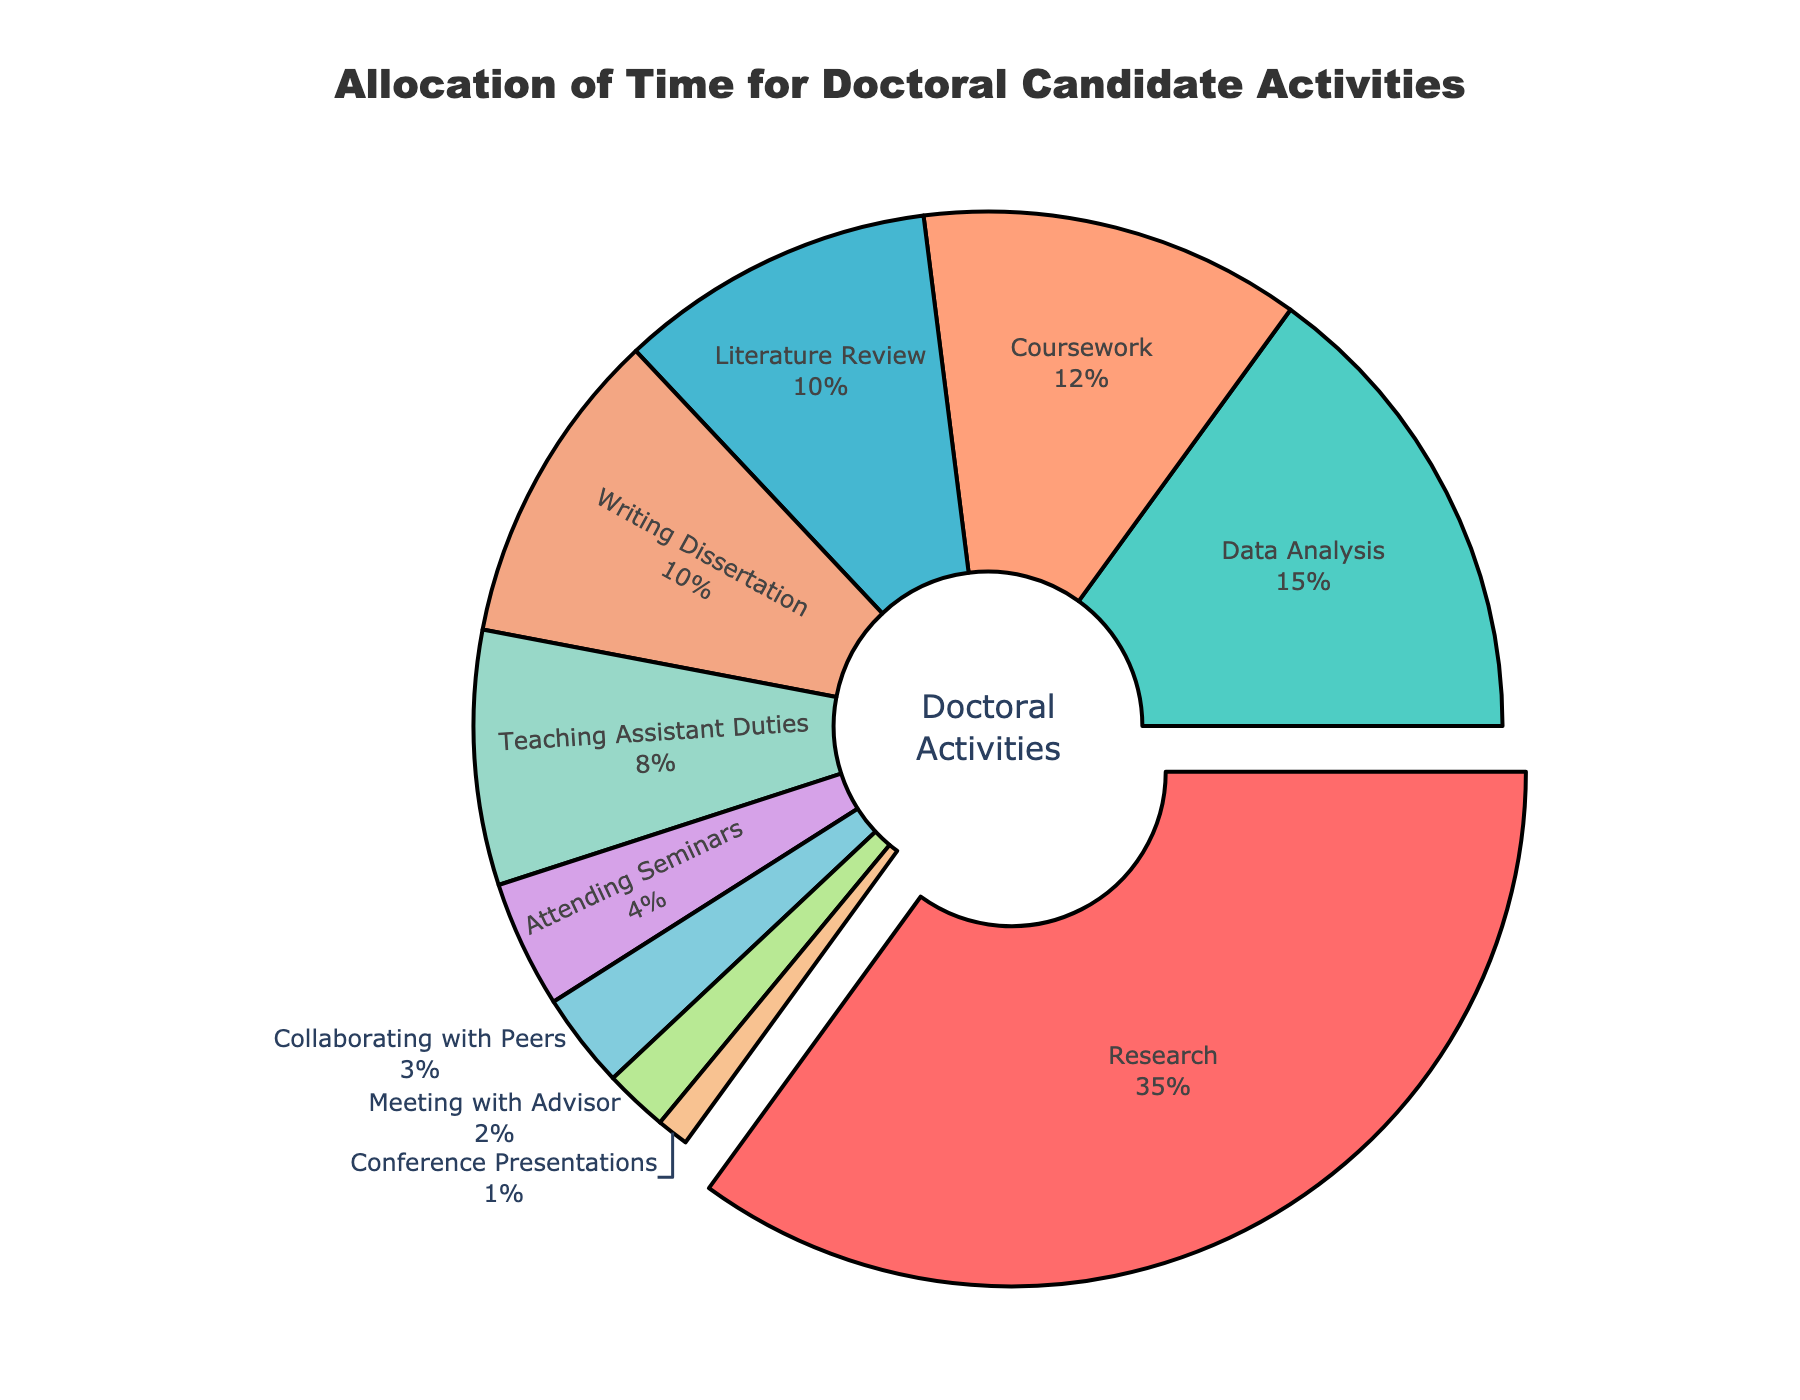What's the largest activity category shown in the pie chart? The largest category is pulled slightly away from the center of the pie chart for emphasis. This can be visually identified without referring to the percentages.
Answer: Research How much more time is spent on Research compared to Teaching Assistant Duties? First, identify the percentages for Research (35%) and Teaching Assistant Duties (8%) from the pie chart. Subtract the two to find the difference: 35% - 8% = 27%
Answer: 27% What is the total percentage of time spent on Writing Dissertation and Literature Review combined? Locate the percentages for Writing Dissertation (10%) and Literature Review (10%). Add these values together: 10% + 10% = 20%
Answer: 20% Which activity is represented by the green color in the pie chart? Identify the green-colored segment in the pie chart and refer to its label. The green color corresponds to Coursework with 12% of time allocation.
Answer: Coursework What percentage of time is spent on activities other than Research and Coursework? Find the percentages for Research (35%) and Coursework (12%). Subtract their sum from 100% to find the percentage spent on activities other than these two: 100% - (35% + 12%) = 100% - 47% = 53%
Answer: 53% How many activities individually account for 10% or more of the total time? Identify the activities with percentages 10% or higher: Research (35%), Writing Dissertation (10%), Coursework (12%), and Data Analysis (15%). There are 4 such activities.
Answer: 4 Which two activities combined have a similar percentage to Data Analysis? Identify the percentage for Data Analysis (15%). Next, look for two activities whose combined percentage approximates 15%. Literature Review (10%) and Attending Seminars (4%) together total 14%, which is closest.
Answer: Literature Review and Attending Seminars What is the median percentage value for all activities? Sort the activities based on their percentages: 1%, 2%, 3%, 4%, 8%, 10%, 10%, 12%, 15%, 35%. The median (middle) value, based on the sorted list, is the average of the 5th and 6th values: (8% + 10%) / 2 = 9%
Answer: 9% Which activity takes up the smallest portion of time and what percentage does it represent? Identify the smallest segment in the pie chart. Conference Presentations account for the least time, represented by 1%.
Answer: Conference Presentations, 1% What is the combined percentage of time spent on Teaching Assistant Duties, Attending Seminars, and Collaborating with Peers? Add the percentages of Teaching Assistant Duties (8%), Attending Seminars (4%), and Collaborating with Peers (3%): 8% + 4% + 3% = 15%
Answer: 15% 